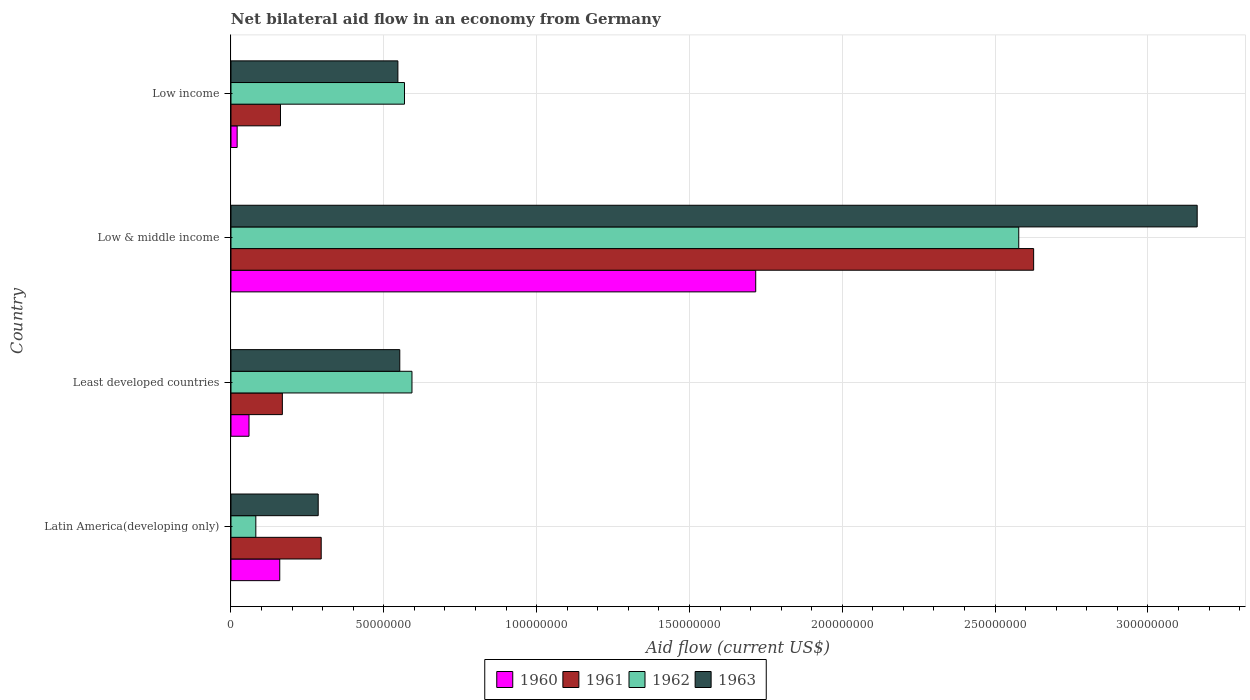Are the number of bars per tick equal to the number of legend labels?
Your answer should be very brief. Yes. How many bars are there on the 1st tick from the top?
Provide a short and direct response. 4. What is the label of the 4th group of bars from the top?
Provide a short and direct response. Latin America(developing only). What is the net bilateral aid flow in 1961 in Low & middle income?
Keep it short and to the point. 2.63e+08. Across all countries, what is the maximum net bilateral aid flow in 1960?
Provide a short and direct response. 1.72e+08. Across all countries, what is the minimum net bilateral aid flow in 1962?
Offer a very short reply. 8.13e+06. In which country was the net bilateral aid flow in 1960 minimum?
Offer a terse response. Low income. What is the total net bilateral aid flow in 1962 in the graph?
Your response must be concise. 3.82e+08. What is the difference between the net bilateral aid flow in 1963 in Latin America(developing only) and that in Least developed countries?
Your answer should be compact. -2.67e+07. What is the difference between the net bilateral aid flow in 1962 in Low income and the net bilateral aid flow in 1963 in Low & middle income?
Offer a very short reply. -2.59e+08. What is the average net bilateral aid flow in 1961 per country?
Ensure brevity in your answer.  8.13e+07. What is the difference between the net bilateral aid flow in 1963 and net bilateral aid flow in 1961 in Latin America(developing only)?
Offer a terse response. -9.80e+05. What is the ratio of the net bilateral aid flow in 1963 in Latin America(developing only) to that in Low income?
Offer a terse response. 0.52. Is the difference between the net bilateral aid flow in 1963 in Least developed countries and Low & middle income greater than the difference between the net bilateral aid flow in 1961 in Least developed countries and Low & middle income?
Your response must be concise. No. What is the difference between the highest and the second highest net bilateral aid flow in 1961?
Make the answer very short. 2.33e+08. What is the difference between the highest and the lowest net bilateral aid flow in 1963?
Offer a terse response. 2.88e+08. What does the 2nd bar from the bottom in Least developed countries represents?
Keep it short and to the point. 1961. How many bars are there?
Your answer should be compact. 16. Are all the bars in the graph horizontal?
Provide a succinct answer. Yes. Are the values on the major ticks of X-axis written in scientific E-notation?
Provide a short and direct response. No. Does the graph contain any zero values?
Give a very brief answer. No. How many legend labels are there?
Your answer should be very brief. 4. What is the title of the graph?
Offer a very short reply. Net bilateral aid flow in an economy from Germany. Does "1978" appear as one of the legend labels in the graph?
Give a very brief answer. No. What is the label or title of the X-axis?
Ensure brevity in your answer.  Aid flow (current US$). What is the label or title of the Y-axis?
Make the answer very short. Country. What is the Aid flow (current US$) of 1960 in Latin America(developing only)?
Offer a terse response. 1.60e+07. What is the Aid flow (current US$) of 1961 in Latin America(developing only)?
Offer a terse response. 2.95e+07. What is the Aid flow (current US$) in 1962 in Latin America(developing only)?
Your answer should be very brief. 8.13e+06. What is the Aid flow (current US$) in 1963 in Latin America(developing only)?
Your response must be concise. 2.85e+07. What is the Aid flow (current US$) in 1960 in Least developed countries?
Keep it short and to the point. 5.90e+06. What is the Aid flow (current US$) of 1961 in Least developed countries?
Your response must be concise. 1.68e+07. What is the Aid flow (current US$) in 1962 in Least developed countries?
Keep it short and to the point. 5.92e+07. What is the Aid flow (current US$) in 1963 in Least developed countries?
Give a very brief answer. 5.52e+07. What is the Aid flow (current US$) of 1960 in Low & middle income?
Ensure brevity in your answer.  1.72e+08. What is the Aid flow (current US$) in 1961 in Low & middle income?
Offer a very short reply. 2.63e+08. What is the Aid flow (current US$) of 1962 in Low & middle income?
Your answer should be very brief. 2.58e+08. What is the Aid flow (current US$) in 1963 in Low & middle income?
Provide a short and direct response. 3.16e+08. What is the Aid flow (current US$) in 1960 in Low income?
Your response must be concise. 2.02e+06. What is the Aid flow (current US$) of 1961 in Low income?
Ensure brevity in your answer.  1.62e+07. What is the Aid flow (current US$) in 1962 in Low income?
Offer a very short reply. 5.68e+07. What is the Aid flow (current US$) of 1963 in Low income?
Your answer should be compact. 5.46e+07. Across all countries, what is the maximum Aid flow (current US$) in 1960?
Your answer should be very brief. 1.72e+08. Across all countries, what is the maximum Aid flow (current US$) of 1961?
Your answer should be very brief. 2.63e+08. Across all countries, what is the maximum Aid flow (current US$) of 1962?
Give a very brief answer. 2.58e+08. Across all countries, what is the maximum Aid flow (current US$) of 1963?
Provide a short and direct response. 3.16e+08. Across all countries, what is the minimum Aid flow (current US$) in 1960?
Your answer should be very brief. 2.02e+06. Across all countries, what is the minimum Aid flow (current US$) of 1961?
Keep it short and to the point. 1.62e+07. Across all countries, what is the minimum Aid flow (current US$) of 1962?
Keep it short and to the point. 8.13e+06. Across all countries, what is the minimum Aid flow (current US$) of 1963?
Make the answer very short. 2.85e+07. What is the total Aid flow (current US$) of 1960 in the graph?
Offer a terse response. 1.96e+08. What is the total Aid flow (current US$) in 1961 in the graph?
Keep it short and to the point. 3.25e+08. What is the total Aid flow (current US$) of 1962 in the graph?
Your answer should be compact. 3.82e+08. What is the total Aid flow (current US$) of 1963 in the graph?
Your response must be concise. 4.55e+08. What is the difference between the Aid flow (current US$) of 1960 in Latin America(developing only) and that in Least developed countries?
Provide a succinct answer. 1.01e+07. What is the difference between the Aid flow (current US$) of 1961 in Latin America(developing only) and that in Least developed countries?
Provide a short and direct response. 1.27e+07. What is the difference between the Aid flow (current US$) in 1962 in Latin America(developing only) and that in Least developed countries?
Your answer should be very brief. -5.11e+07. What is the difference between the Aid flow (current US$) of 1963 in Latin America(developing only) and that in Least developed countries?
Keep it short and to the point. -2.67e+07. What is the difference between the Aid flow (current US$) in 1960 in Latin America(developing only) and that in Low & middle income?
Make the answer very short. -1.56e+08. What is the difference between the Aid flow (current US$) in 1961 in Latin America(developing only) and that in Low & middle income?
Make the answer very short. -2.33e+08. What is the difference between the Aid flow (current US$) in 1962 in Latin America(developing only) and that in Low & middle income?
Offer a very short reply. -2.50e+08. What is the difference between the Aid flow (current US$) in 1963 in Latin America(developing only) and that in Low & middle income?
Give a very brief answer. -2.88e+08. What is the difference between the Aid flow (current US$) in 1960 in Latin America(developing only) and that in Low income?
Offer a terse response. 1.39e+07. What is the difference between the Aid flow (current US$) of 1961 in Latin America(developing only) and that in Low income?
Your answer should be very brief. 1.33e+07. What is the difference between the Aid flow (current US$) in 1962 in Latin America(developing only) and that in Low income?
Keep it short and to the point. -4.86e+07. What is the difference between the Aid flow (current US$) in 1963 in Latin America(developing only) and that in Low income?
Provide a succinct answer. -2.61e+07. What is the difference between the Aid flow (current US$) of 1960 in Least developed countries and that in Low & middle income?
Offer a very short reply. -1.66e+08. What is the difference between the Aid flow (current US$) of 1961 in Least developed countries and that in Low & middle income?
Offer a very short reply. -2.46e+08. What is the difference between the Aid flow (current US$) in 1962 in Least developed countries and that in Low & middle income?
Make the answer very short. -1.99e+08. What is the difference between the Aid flow (current US$) of 1963 in Least developed countries and that in Low & middle income?
Your answer should be very brief. -2.61e+08. What is the difference between the Aid flow (current US$) in 1960 in Least developed countries and that in Low income?
Offer a very short reply. 3.88e+06. What is the difference between the Aid flow (current US$) in 1962 in Least developed countries and that in Low income?
Provide a short and direct response. 2.45e+06. What is the difference between the Aid flow (current US$) in 1963 in Least developed countries and that in Low income?
Your answer should be very brief. 6.20e+05. What is the difference between the Aid flow (current US$) in 1960 in Low & middle income and that in Low income?
Provide a succinct answer. 1.70e+08. What is the difference between the Aid flow (current US$) of 1961 in Low & middle income and that in Low income?
Ensure brevity in your answer.  2.46e+08. What is the difference between the Aid flow (current US$) in 1962 in Low & middle income and that in Low income?
Offer a very short reply. 2.01e+08. What is the difference between the Aid flow (current US$) of 1963 in Low & middle income and that in Low income?
Give a very brief answer. 2.62e+08. What is the difference between the Aid flow (current US$) in 1960 in Latin America(developing only) and the Aid flow (current US$) in 1961 in Least developed countries?
Offer a very short reply. -8.50e+05. What is the difference between the Aid flow (current US$) in 1960 in Latin America(developing only) and the Aid flow (current US$) in 1962 in Least developed countries?
Your response must be concise. -4.33e+07. What is the difference between the Aid flow (current US$) in 1960 in Latin America(developing only) and the Aid flow (current US$) in 1963 in Least developed countries?
Your answer should be compact. -3.93e+07. What is the difference between the Aid flow (current US$) of 1961 in Latin America(developing only) and the Aid flow (current US$) of 1962 in Least developed countries?
Your response must be concise. -2.97e+07. What is the difference between the Aid flow (current US$) of 1961 in Latin America(developing only) and the Aid flow (current US$) of 1963 in Least developed countries?
Provide a succinct answer. -2.57e+07. What is the difference between the Aid flow (current US$) in 1962 in Latin America(developing only) and the Aid flow (current US$) in 1963 in Least developed countries?
Offer a very short reply. -4.71e+07. What is the difference between the Aid flow (current US$) of 1960 in Latin America(developing only) and the Aid flow (current US$) of 1961 in Low & middle income?
Keep it short and to the point. -2.47e+08. What is the difference between the Aid flow (current US$) of 1960 in Latin America(developing only) and the Aid flow (current US$) of 1962 in Low & middle income?
Your response must be concise. -2.42e+08. What is the difference between the Aid flow (current US$) of 1960 in Latin America(developing only) and the Aid flow (current US$) of 1963 in Low & middle income?
Make the answer very short. -3.00e+08. What is the difference between the Aid flow (current US$) in 1961 in Latin America(developing only) and the Aid flow (current US$) in 1962 in Low & middle income?
Ensure brevity in your answer.  -2.28e+08. What is the difference between the Aid flow (current US$) in 1961 in Latin America(developing only) and the Aid flow (current US$) in 1963 in Low & middle income?
Ensure brevity in your answer.  -2.87e+08. What is the difference between the Aid flow (current US$) in 1962 in Latin America(developing only) and the Aid flow (current US$) in 1963 in Low & middle income?
Give a very brief answer. -3.08e+08. What is the difference between the Aid flow (current US$) of 1960 in Latin America(developing only) and the Aid flow (current US$) of 1961 in Low income?
Your answer should be very brief. -2.40e+05. What is the difference between the Aid flow (current US$) of 1960 in Latin America(developing only) and the Aid flow (current US$) of 1962 in Low income?
Keep it short and to the point. -4.08e+07. What is the difference between the Aid flow (current US$) of 1960 in Latin America(developing only) and the Aid flow (current US$) of 1963 in Low income?
Offer a terse response. -3.86e+07. What is the difference between the Aid flow (current US$) in 1961 in Latin America(developing only) and the Aid flow (current US$) in 1962 in Low income?
Make the answer very short. -2.72e+07. What is the difference between the Aid flow (current US$) in 1961 in Latin America(developing only) and the Aid flow (current US$) in 1963 in Low income?
Provide a succinct answer. -2.51e+07. What is the difference between the Aid flow (current US$) of 1962 in Latin America(developing only) and the Aid flow (current US$) of 1963 in Low income?
Your response must be concise. -4.65e+07. What is the difference between the Aid flow (current US$) of 1960 in Least developed countries and the Aid flow (current US$) of 1961 in Low & middle income?
Your answer should be very brief. -2.57e+08. What is the difference between the Aid flow (current US$) in 1960 in Least developed countries and the Aid flow (current US$) in 1962 in Low & middle income?
Offer a very short reply. -2.52e+08. What is the difference between the Aid flow (current US$) in 1960 in Least developed countries and the Aid flow (current US$) in 1963 in Low & middle income?
Provide a short and direct response. -3.10e+08. What is the difference between the Aid flow (current US$) in 1961 in Least developed countries and the Aid flow (current US$) in 1962 in Low & middle income?
Keep it short and to the point. -2.41e+08. What is the difference between the Aid flow (current US$) of 1961 in Least developed countries and the Aid flow (current US$) of 1963 in Low & middle income?
Offer a very short reply. -2.99e+08. What is the difference between the Aid flow (current US$) in 1962 in Least developed countries and the Aid flow (current US$) in 1963 in Low & middle income?
Offer a terse response. -2.57e+08. What is the difference between the Aid flow (current US$) of 1960 in Least developed countries and the Aid flow (current US$) of 1961 in Low income?
Your answer should be very brief. -1.03e+07. What is the difference between the Aid flow (current US$) of 1960 in Least developed countries and the Aid flow (current US$) of 1962 in Low income?
Give a very brief answer. -5.09e+07. What is the difference between the Aid flow (current US$) of 1960 in Least developed countries and the Aid flow (current US$) of 1963 in Low income?
Provide a short and direct response. -4.87e+07. What is the difference between the Aid flow (current US$) in 1961 in Least developed countries and the Aid flow (current US$) in 1962 in Low income?
Give a very brief answer. -4.00e+07. What is the difference between the Aid flow (current US$) in 1961 in Least developed countries and the Aid flow (current US$) in 1963 in Low income?
Give a very brief answer. -3.78e+07. What is the difference between the Aid flow (current US$) of 1962 in Least developed countries and the Aid flow (current US$) of 1963 in Low income?
Your response must be concise. 4.61e+06. What is the difference between the Aid flow (current US$) in 1960 in Low & middle income and the Aid flow (current US$) in 1961 in Low income?
Your answer should be compact. 1.55e+08. What is the difference between the Aid flow (current US$) of 1960 in Low & middle income and the Aid flow (current US$) of 1962 in Low income?
Make the answer very short. 1.15e+08. What is the difference between the Aid flow (current US$) in 1960 in Low & middle income and the Aid flow (current US$) in 1963 in Low income?
Keep it short and to the point. 1.17e+08. What is the difference between the Aid flow (current US$) in 1961 in Low & middle income and the Aid flow (current US$) in 1962 in Low income?
Make the answer very short. 2.06e+08. What is the difference between the Aid flow (current US$) of 1961 in Low & middle income and the Aid flow (current US$) of 1963 in Low income?
Your answer should be very brief. 2.08e+08. What is the difference between the Aid flow (current US$) of 1962 in Low & middle income and the Aid flow (current US$) of 1963 in Low income?
Offer a very short reply. 2.03e+08. What is the average Aid flow (current US$) of 1960 per country?
Your answer should be very brief. 4.89e+07. What is the average Aid flow (current US$) in 1961 per country?
Keep it short and to the point. 8.13e+07. What is the average Aid flow (current US$) of 1962 per country?
Your response must be concise. 9.55e+07. What is the average Aid flow (current US$) of 1963 per country?
Your answer should be very brief. 1.14e+08. What is the difference between the Aid flow (current US$) in 1960 and Aid flow (current US$) in 1961 in Latin America(developing only)?
Your answer should be very brief. -1.36e+07. What is the difference between the Aid flow (current US$) of 1960 and Aid flow (current US$) of 1962 in Latin America(developing only)?
Provide a short and direct response. 7.83e+06. What is the difference between the Aid flow (current US$) of 1960 and Aid flow (current US$) of 1963 in Latin America(developing only)?
Give a very brief answer. -1.26e+07. What is the difference between the Aid flow (current US$) of 1961 and Aid flow (current US$) of 1962 in Latin America(developing only)?
Keep it short and to the point. 2.14e+07. What is the difference between the Aid flow (current US$) of 1961 and Aid flow (current US$) of 1963 in Latin America(developing only)?
Provide a short and direct response. 9.80e+05. What is the difference between the Aid flow (current US$) in 1962 and Aid flow (current US$) in 1963 in Latin America(developing only)?
Your answer should be compact. -2.04e+07. What is the difference between the Aid flow (current US$) of 1960 and Aid flow (current US$) of 1961 in Least developed countries?
Keep it short and to the point. -1.09e+07. What is the difference between the Aid flow (current US$) of 1960 and Aid flow (current US$) of 1962 in Least developed countries?
Provide a short and direct response. -5.33e+07. What is the difference between the Aid flow (current US$) in 1960 and Aid flow (current US$) in 1963 in Least developed countries?
Make the answer very short. -4.93e+07. What is the difference between the Aid flow (current US$) of 1961 and Aid flow (current US$) of 1962 in Least developed countries?
Provide a succinct answer. -4.24e+07. What is the difference between the Aid flow (current US$) of 1961 and Aid flow (current US$) of 1963 in Least developed countries?
Offer a very short reply. -3.84e+07. What is the difference between the Aid flow (current US$) in 1962 and Aid flow (current US$) in 1963 in Least developed countries?
Your response must be concise. 3.99e+06. What is the difference between the Aid flow (current US$) of 1960 and Aid flow (current US$) of 1961 in Low & middle income?
Provide a succinct answer. -9.09e+07. What is the difference between the Aid flow (current US$) in 1960 and Aid flow (current US$) in 1962 in Low & middle income?
Keep it short and to the point. -8.61e+07. What is the difference between the Aid flow (current US$) in 1960 and Aid flow (current US$) in 1963 in Low & middle income?
Keep it short and to the point. -1.44e+08. What is the difference between the Aid flow (current US$) in 1961 and Aid flow (current US$) in 1962 in Low & middle income?
Make the answer very short. 4.87e+06. What is the difference between the Aid flow (current US$) of 1961 and Aid flow (current US$) of 1963 in Low & middle income?
Give a very brief answer. -5.35e+07. What is the difference between the Aid flow (current US$) in 1962 and Aid flow (current US$) in 1963 in Low & middle income?
Make the answer very short. -5.84e+07. What is the difference between the Aid flow (current US$) of 1960 and Aid flow (current US$) of 1961 in Low income?
Your answer should be compact. -1.42e+07. What is the difference between the Aid flow (current US$) in 1960 and Aid flow (current US$) in 1962 in Low income?
Offer a terse response. -5.48e+07. What is the difference between the Aid flow (current US$) in 1960 and Aid flow (current US$) in 1963 in Low income?
Your answer should be compact. -5.26e+07. What is the difference between the Aid flow (current US$) in 1961 and Aid flow (current US$) in 1962 in Low income?
Ensure brevity in your answer.  -4.06e+07. What is the difference between the Aid flow (current US$) in 1961 and Aid flow (current US$) in 1963 in Low income?
Your response must be concise. -3.84e+07. What is the difference between the Aid flow (current US$) in 1962 and Aid flow (current US$) in 1963 in Low income?
Ensure brevity in your answer.  2.16e+06. What is the ratio of the Aid flow (current US$) of 1960 in Latin America(developing only) to that in Least developed countries?
Give a very brief answer. 2.71. What is the ratio of the Aid flow (current US$) in 1961 in Latin America(developing only) to that in Least developed countries?
Give a very brief answer. 1.76. What is the ratio of the Aid flow (current US$) of 1962 in Latin America(developing only) to that in Least developed countries?
Give a very brief answer. 0.14. What is the ratio of the Aid flow (current US$) of 1963 in Latin America(developing only) to that in Least developed countries?
Your answer should be very brief. 0.52. What is the ratio of the Aid flow (current US$) in 1960 in Latin America(developing only) to that in Low & middle income?
Keep it short and to the point. 0.09. What is the ratio of the Aid flow (current US$) in 1961 in Latin America(developing only) to that in Low & middle income?
Your response must be concise. 0.11. What is the ratio of the Aid flow (current US$) in 1962 in Latin America(developing only) to that in Low & middle income?
Offer a very short reply. 0.03. What is the ratio of the Aid flow (current US$) in 1963 in Latin America(developing only) to that in Low & middle income?
Ensure brevity in your answer.  0.09. What is the ratio of the Aid flow (current US$) in 1960 in Latin America(developing only) to that in Low income?
Provide a short and direct response. 7.9. What is the ratio of the Aid flow (current US$) in 1961 in Latin America(developing only) to that in Low income?
Keep it short and to the point. 1.82. What is the ratio of the Aid flow (current US$) of 1962 in Latin America(developing only) to that in Low income?
Provide a succinct answer. 0.14. What is the ratio of the Aid flow (current US$) of 1963 in Latin America(developing only) to that in Low income?
Provide a succinct answer. 0.52. What is the ratio of the Aid flow (current US$) of 1960 in Least developed countries to that in Low & middle income?
Your response must be concise. 0.03. What is the ratio of the Aid flow (current US$) of 1961 in Least developed countries to that in Low & middle income?
Keep it short and to the point. 0.06. What is the ratio of the Aid flow (current US$) of 1962 in Least developed countries to that in Low & middle income?
Keep it short and to the point. 0.23. What is the ratio of the Aid flow (current US$) in 1963 in Least developed countries to that in Low & middle income?
Offer a terse response. 0.17. What is the ratio of the Aid flow (current US$) of 1960 in Least developed countries to that in Low income?
Make the answer very short. 2.92. What is the ratio of the Aid flow (current US$) of 1961 in Least developed countries to that in Low income?
Your answer should be compact. 1.04. What is the ratio of the Aid flow (current US$) of 1962 in Least developed countries to that in Low income?
Your answer should be very brief. 1.04. What is the ratio of the Aid flow (current US$) in 1963 in Least developed countries to that in Low income?
Your answer should be compact. 1.01. What is the ratio of the Aid flow (current US$) of 1960 in Low & middle income to that in Low income?
Ensure brevity in your answer.  85. What is the ratio of the Aid flow (current US$) in 1961 in Low & middle income to that in Low income?
Ensure brevity in your answer.  16.21. What is the ratio of the Aid flow (current US$) of 1962 in Low & middle income to that in Low income?
Provide a succinct answer. 4.54. What is the ratio of the Aid flow (current US$) of 1963 in Low & middle income to that in Low income?
Your answer should be very brief. 5.79. What is the difference between the highest and the second highest Aid flow (current US$) in 1960?
Your answer should be very brief. 1.56e+08. What is the difference between the highest and the second highest Aid flow (current US$) in 1961?
Ensure brevity in your answer.  2.33e+08. What is the difference between the highest and the second highest Aid flow (current US$) in 1962?
Make the answer very short. 1.99e+08. What is the difference between the highest and the second highest Aid flow (current US$) in 1963?
Offer a very short reply. 2.61e+08. What is the difference between the highest and the lowest Aid flow (current US$) of 1960?
Your answer should be compact. 1.70e+08. What is the difference between the highest and the lowest Aid flow (current US$) of 1961?
Keep it short and to the point. 2.46e+08. What is the difference between the highest and the lowest Aid flow (current US$) of 1962?
Give a very brief answer. 2.50e+08. What is the difference between the highest and the lowest Aid flow (current US$) in 1963?
Provide a short and direct response. 2.88e+08. 